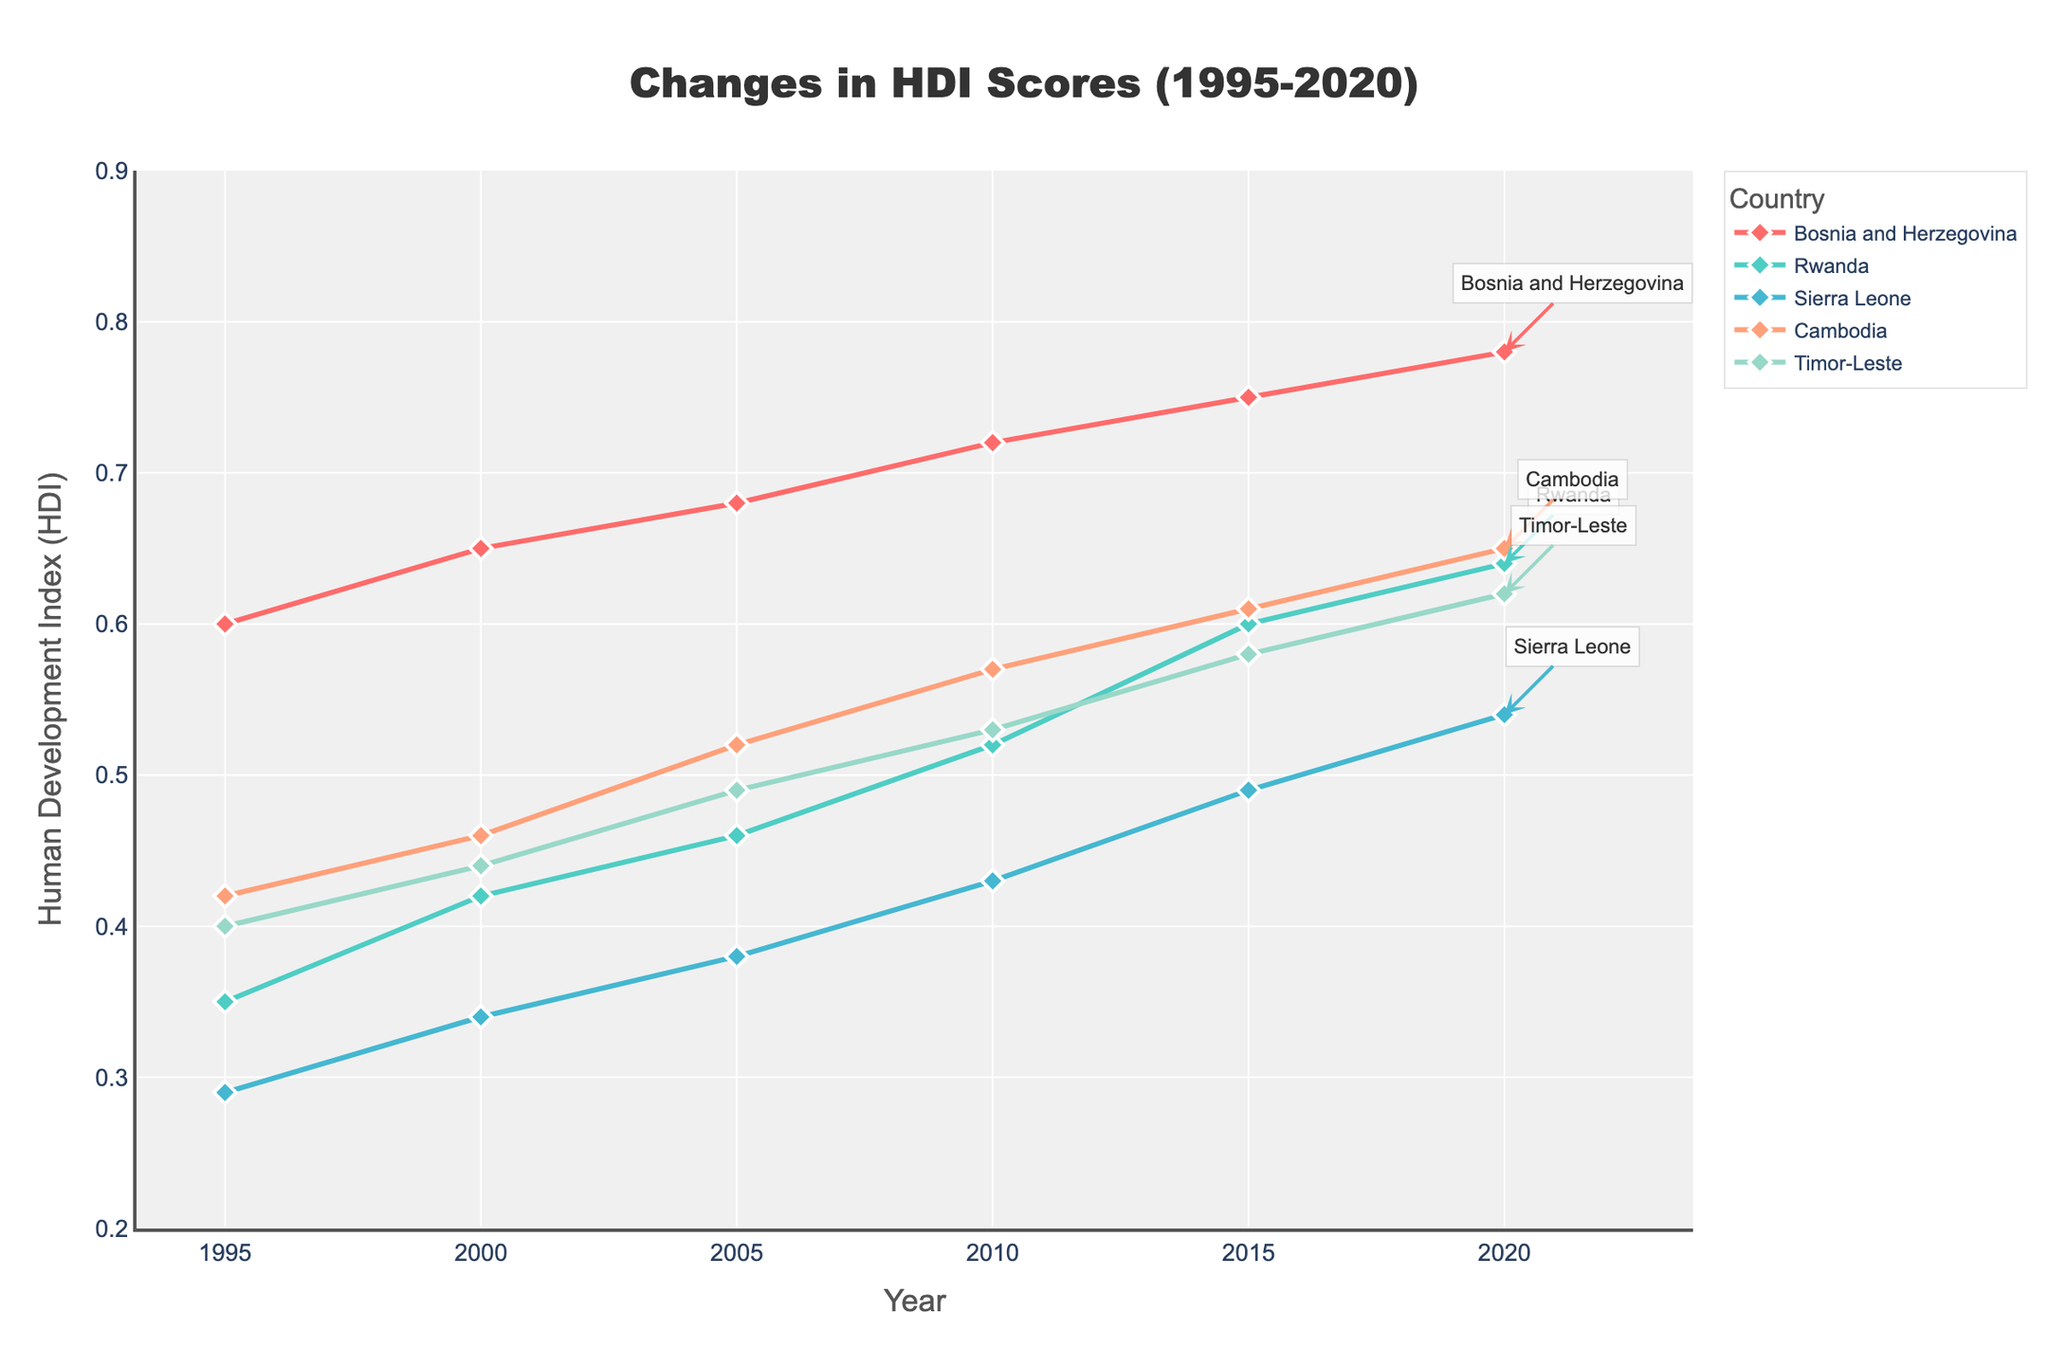What is the title of the plot? The title of the plot can be found at the top of the figure, typically in a larger font size. It represents the overall subject of the figure.
Answer: Changes in HDI Scores (1995-2020) What is the HDI score for Bosnia and Herzegovina in 2005? To determine this, look for the point on the line corresponding to Bosnia and Herzegovina at the year 2005 on the x-axis and read the corresponding value on the y-axis.
Answer: 0.680 Which country experienced the largest increase in HDI score from 1995 to 2020? Calculate the difference between the HDI score in 2020 and the HDI score in 1995 for each country, then compare these differences to find the largest one. For example, Bosnia and Herzegovina increased by 0.780 - 0.600 = 0.180.
Answer: Rwanda How does the HDI improvement trend of Rwanda compare to that of Cambodia? Analyzing the slope of the lines for both countries from 1995 to 2020, we see that Rwanda's line is steeper, indicating a higher rate of improvement in HDI compared to Cambodia.
Answer: Rwanda's trend shows a higher rate of improvement What is the average HDI score for Sierra Leone across all given years? Sum up the HDI scores for Sierra Leone from 1995 to 2020 and then divide by the number of years (6). The sum is 0.290 + 0.340 + 0.380 + 0.430 + 0.490 + 0.540 = 2.47, and the average is 2.47 / 6 = 0.4117.
Answer: 0.4117 Which country's HDI score surpassed another's between 2015 and 2020? Compare the HDI scores of each country at 2015 and 2020. For instance, Rwanda had an HDI score of 0.600 in 2015 and surpassed Timor-Leste which had an HDI score of 0.580 in 2015 by reaching 0.640 in 2020.
Answer: Rwanda surpassed Timor-Leste Which country had the lowest HDI score in 1995? Identify the point with the lowest value on the y-axis for the year 1995. This is the data point closer to the bottom of the y-axis value range.
Answer: Sierra Leone What's the range of the y-axis? Examine the y-axis to find the minimum and maximum values displayed. The y-axis starts at 0.2 and ends at 0.9.
Answer: 0.2 to 0.9 Is there a visible common trend among all nations in the plot? Observe the general inclination of the lines for all countries from the start year to the end year. Every line shows an increasing trend, indicating improvements in HDI for all nations.
Answer: Yes, all nations show an increasing trend in HDI Between which years did Bosnia and Herzegovina have the smallest increase in HDI? Compare the values year by year for Bosnia and Herzegovina. The smallest increase occurs between the years with the least difference in HDI values. For example, between 2005 (0.680) and 2010 (0.720), the increase is 0.720 - 0.680 = 0.040, which is smaller compared to other year intervals.
Answer: 2005 to 2010 